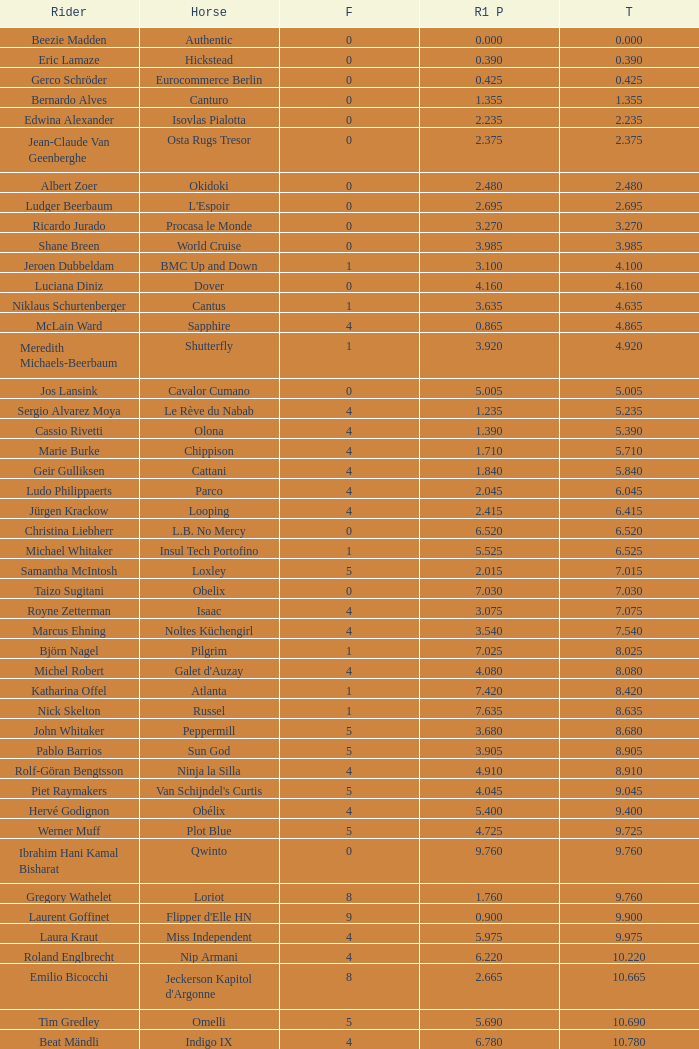Tell me the rider with 18.185 points round 1 Veronika Macanova. 